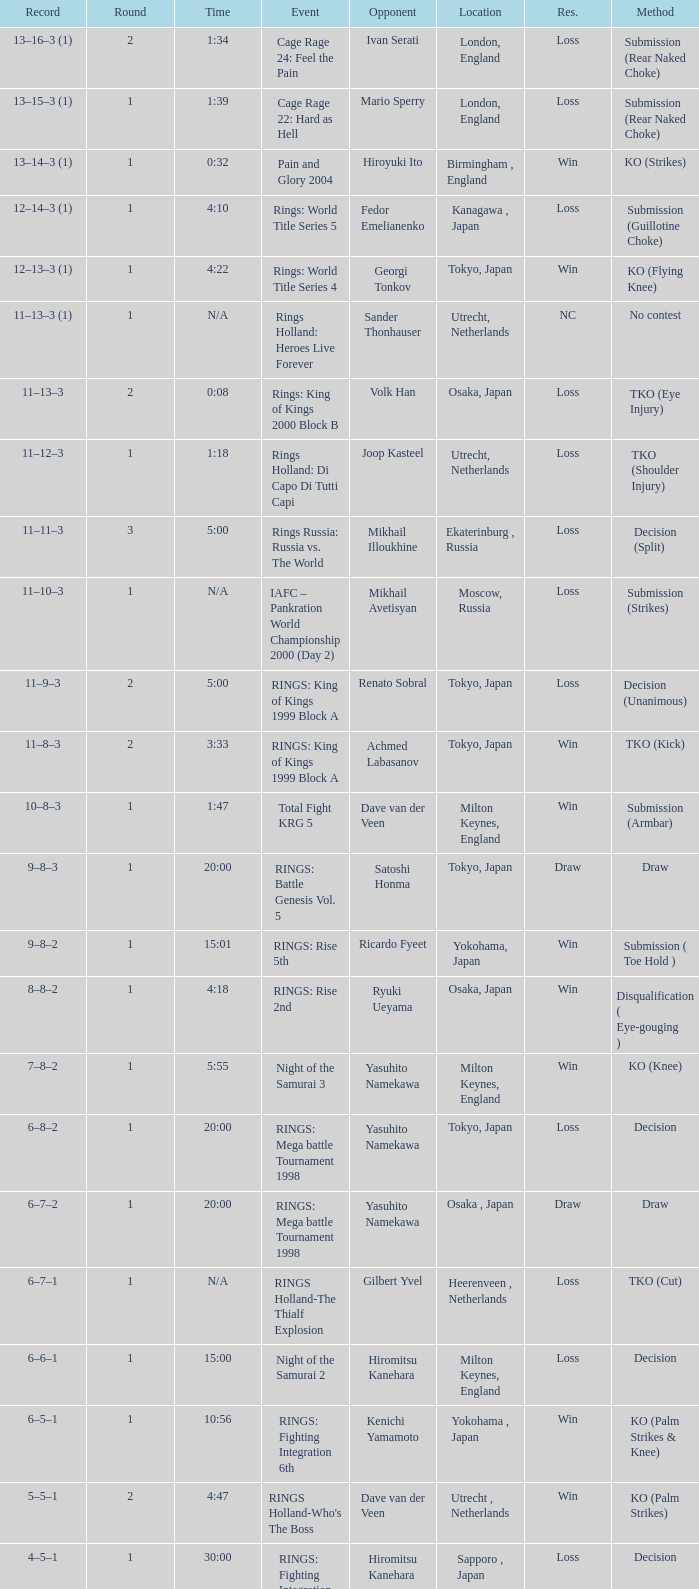Who was the opponent in London, England in a round less than 2? Mario Sperry. 